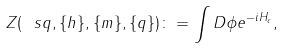Convert formula to latex. <formula><loc_0><loc_0><loc_500><loc_500>Z ( \ s q , \{ h \} , \{ m \} , \{ q \} ) \colon = \int D \phi e ^ { - i H _ { c } } ,</formula> 